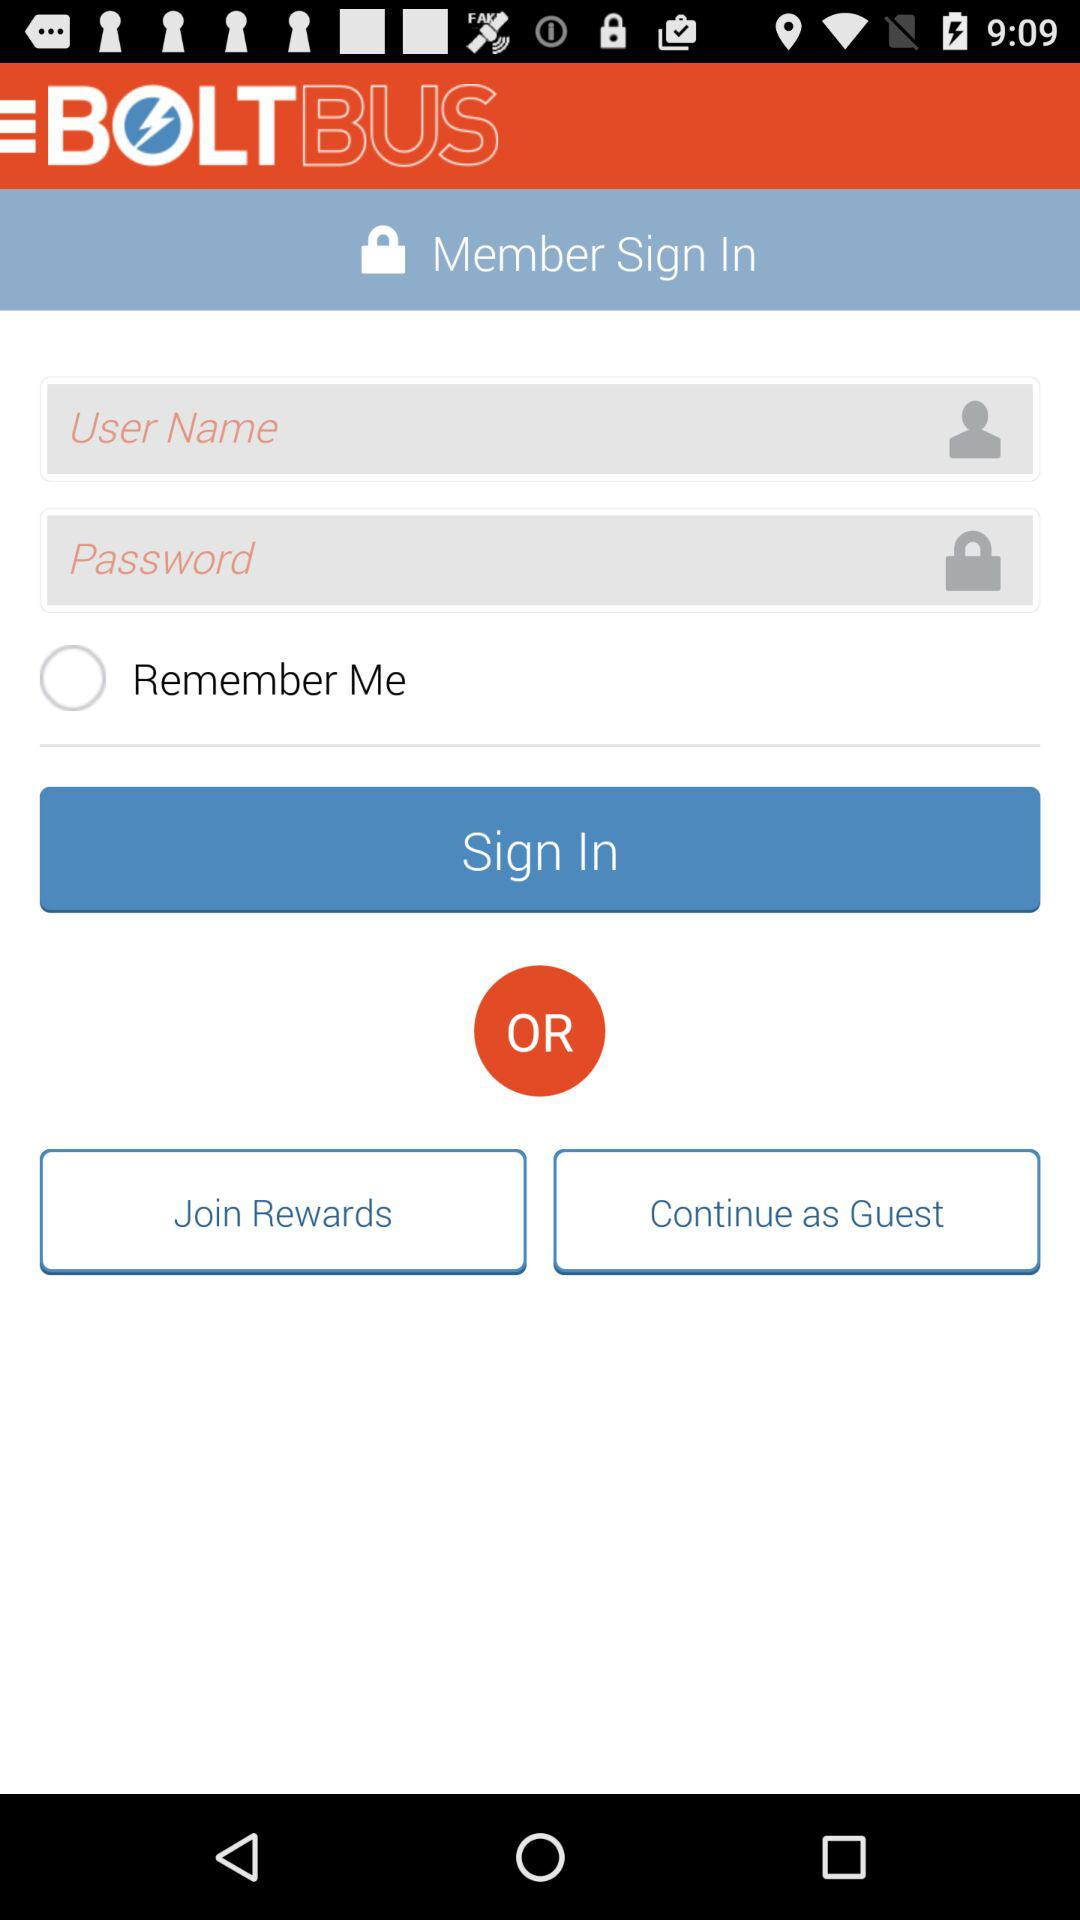What is the name of the application? The name of the application is "BOLTBUS". 